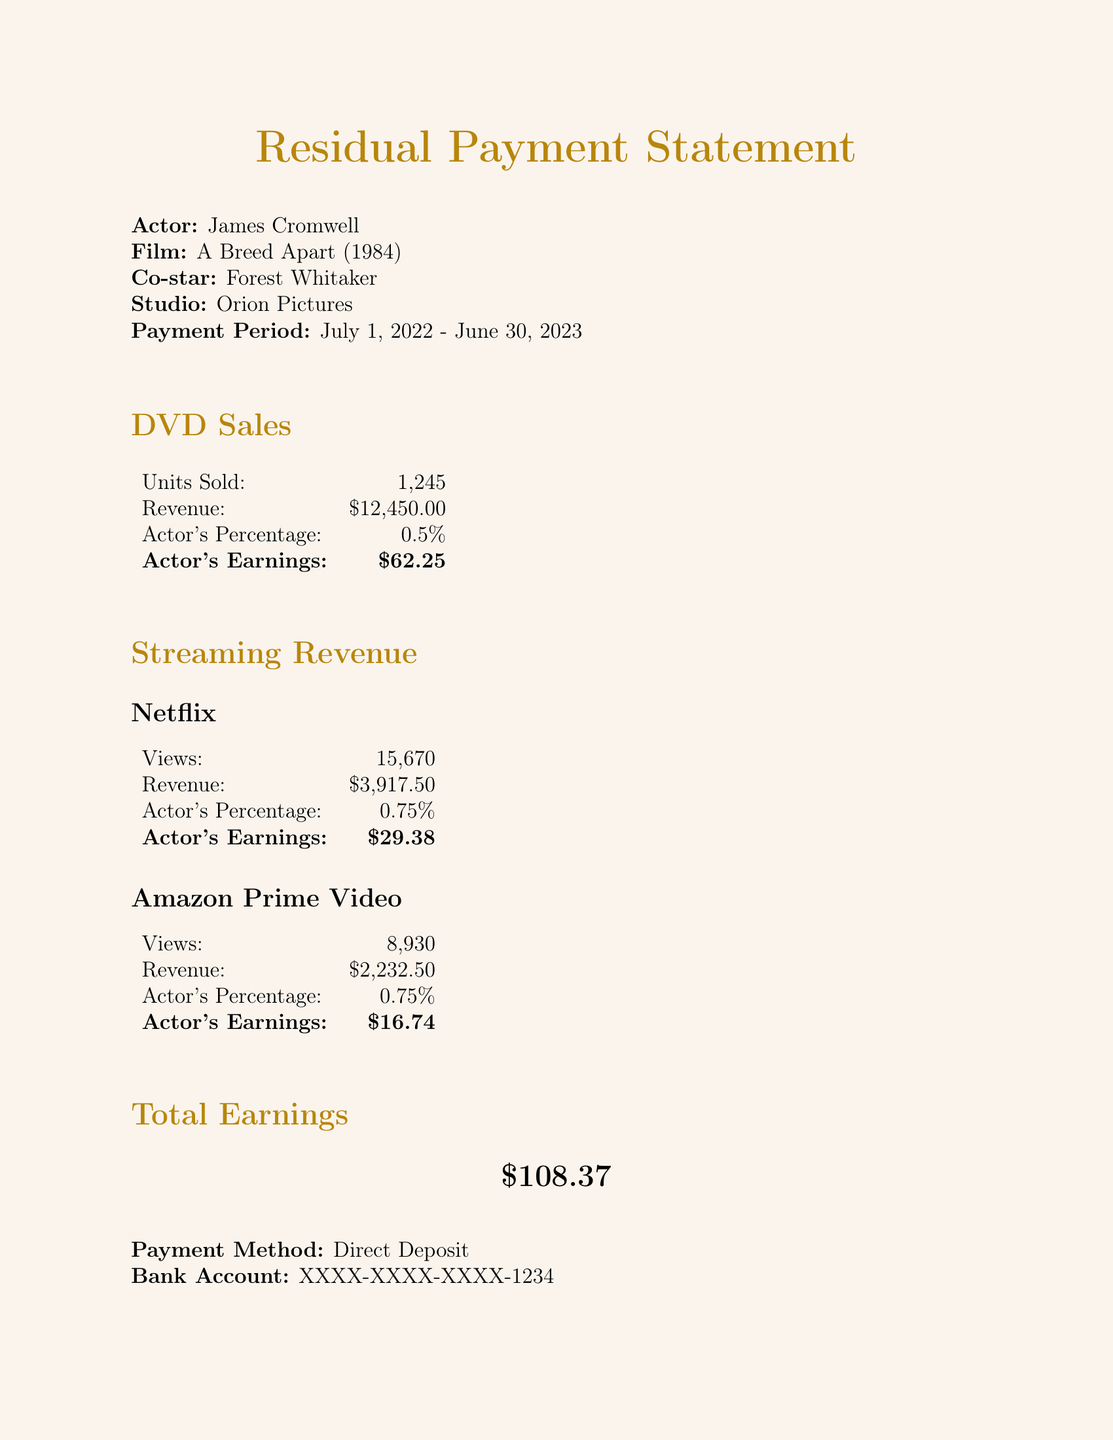what is the film's title? The film title is mentioned at the top of the document as "A Breed Apart."
Answer: A Breed Apart who is the co-star? The document states that the co-star is Forest Whitaker.
Answer: Forest Whitaker what is the total earnings for the payment period? The total earnings are highlighted in the section for Total Earnings as $108.37.
Answer: $108.37 what is the revenue from DVD sales? The revenue from DVD sales is listed as $12,450.00 in the DVD Sales section.
Answer: $12,450.00 how many units were sold in DVD sales? The document indicates that 1,245 units were sold in DVD sales.
Answer: 1,245 what percentage of streaming revenue does the actor earn from Netflix? The document shows that the actor's percentage from Netflix is 0.75%.
Answer: 0.75% which platform generated the most revenue in streaming? The revenues from Netflix and Amazon are present, and Netflix has $3,917.50 while Amazon has $2,232.50, making Netflix the highest.
Answer: Netflix how is the payment made? The method of payment is specified as Direct Deposit in the document.
Answer: Direct Deposit what is the actor's earnings from Amazon Prime Video? The document specifies that the actor's earnings from Amazon Prime Video are $16.74.
Answer: $16.74 